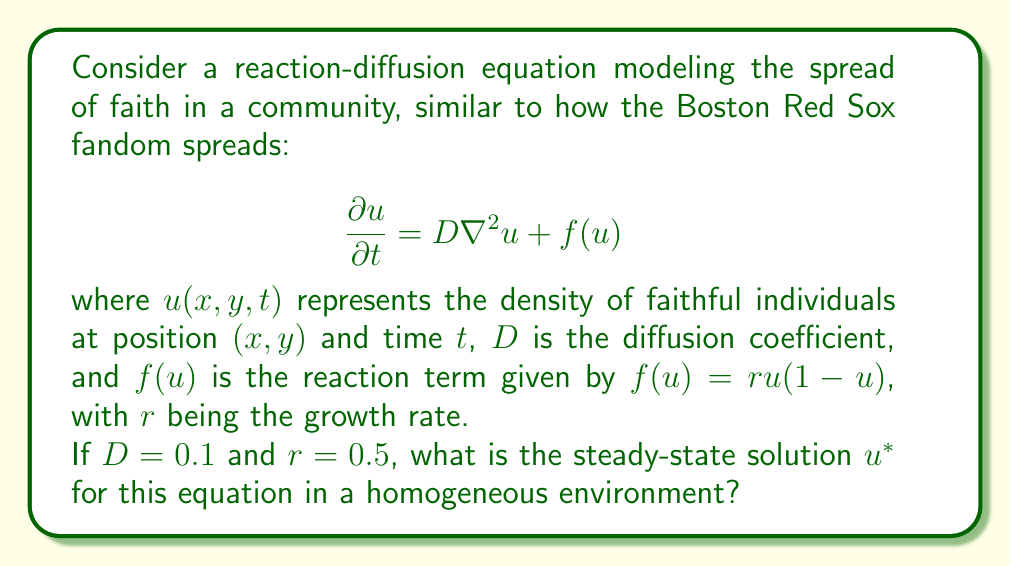Can you answer this question? To find the steady-state solution, we need to consider the equation when the system is not changing with time. This means setting $\frac{\partial u}{\partial t} = 0$:

$$0 = D\nabla^2u + f(u)$$

In a homogeneous environment, spatial variations are negligible, so $\nabla^2u = 0$. This simplifies our equation to:

$$0 = f(u)$$

Substituting the given reaction term:

$$0 = ru(1-u)$$

Now, let's solve this equation:

1) Factor out $r$:
   $$0 = r[u(1-u)]$$

2) Since $r \neq 0$ (given as 0.5), we can divide both sides by $r$:
   $$0 = u(1-u)$$

3) This equation has two solutions:
   a) $u = 0$
   b) $1 - u = 0$, which means $u = 1$

The steady-state solutions are therefore $u^* = 0$ and $u^* = 1$.

Interpreting these results:
- $u^* = 0$ represents a state where faith has died out in the community.
- $u^* = 1$ represents a state where faith has spread to the entire community.

In the context of our faith-spreading model, $u^* = 1$ is the more relevant and stable solution, as it represents the complete spread of faith throughout the community.
Answer: The steady-state solution is $u^* = 1$. 